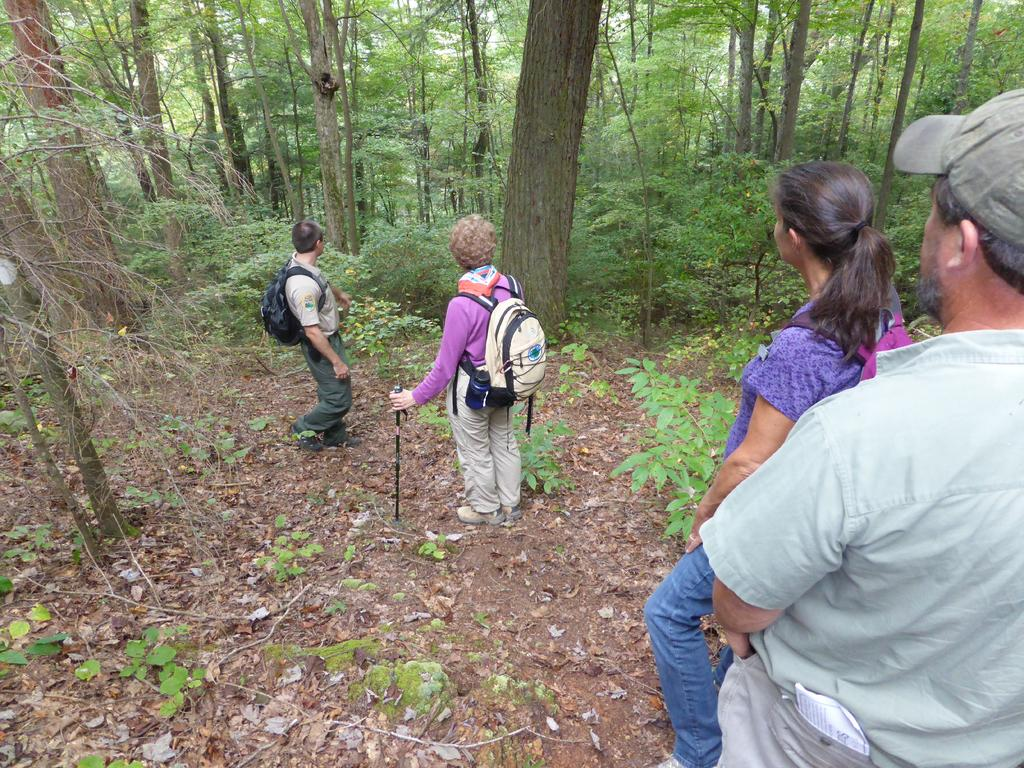What is the composition of the group in the image? There is a group of men and women in the image. Where is the group located? The group is standing in a forest. What can be seen in the background of the image? There are many tall trees in the background of the image. What type of answer is being given by the army in the image? There is no army present in the image, and therefore no answers are being given. 